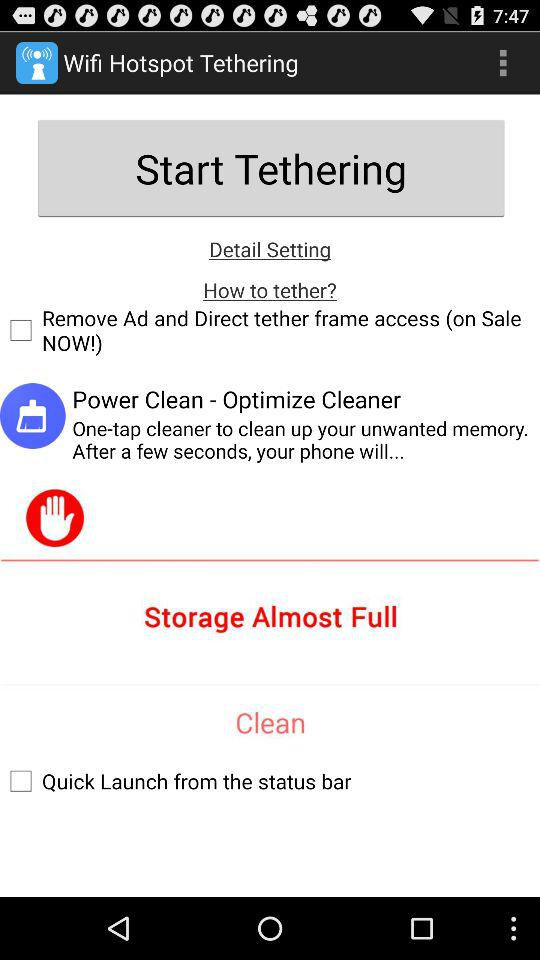What is the application name? The application name is "Wifi Hotspot Tethering". 